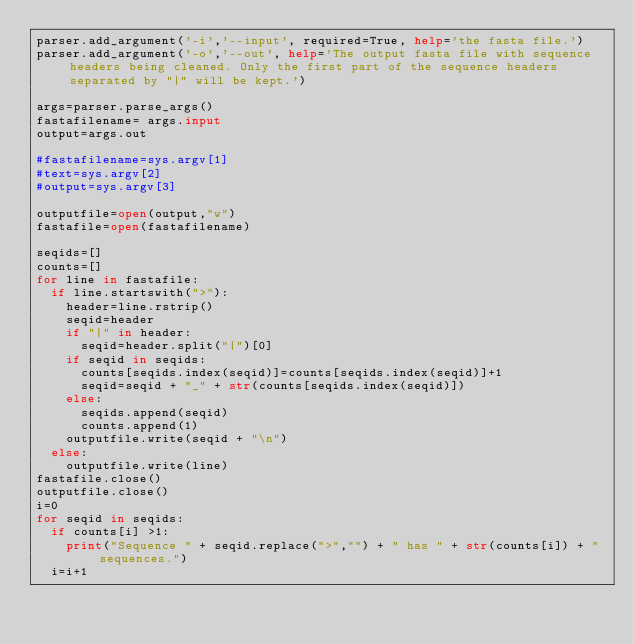Convert code to text. <code><loc_0><loc_0><loc_500><loc_500><_Python_>parser.add_argument('-i','--input', required=True, help='the fasta file.')
parser.add_argument('-o','--out', help='The output fasta file with sequence headers being cleaned. Only the first part of the sequence headers separated by "|" will be kept.')

args=parser.parse_args()
fastafilename= args.input
output=args.out

#fastafilename=sys.argv[1]
#text=sys.argv[2]
#output=sys.argv[3]

outputfile=open(output,"w")
fastafile=open(fastafilename)

seqids=[]
counts=[]
for line in fastafile:
	if line.startswith(">"):
		header=line.rstrip()
		seqid=header
		if "|" in header:
			seqid=header.split("|")[0]	
		if seqid in seqids:
			counts[seqids.index(seqid)]=counts[seqids.index(seqid)]+1
			seqid=seqid + "_" + str(counts[seqids.index(seqid)])
		else:	
			seqids.append(seqid)
			counts.append(1)
		outputfile.write(seqid + "\n")	
	else:		
		outputfile.write(line)
fastafile.close()
outputfile.close()		
i=0
for seqid in seqids:
	if counts[i] >1:
		print("Sequence " + seqid.replace(">","") + " has " + str(counts[i]) + " sequences.")
	i=i+1

</code> 